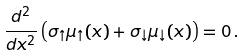Convert formula to latex. <formula><loc_0><loc_0><loc_500><loc_500>\frac { d ^ { 2 } } { d x ^ { 2 } } \left ( \sigma _ { \uparrow } \mu _ { \uparrow } ( x ) + \sigma _ { \downarrow } \mu _ { \downarrow } ( x ) \right ) = 0 \, .</formula> 